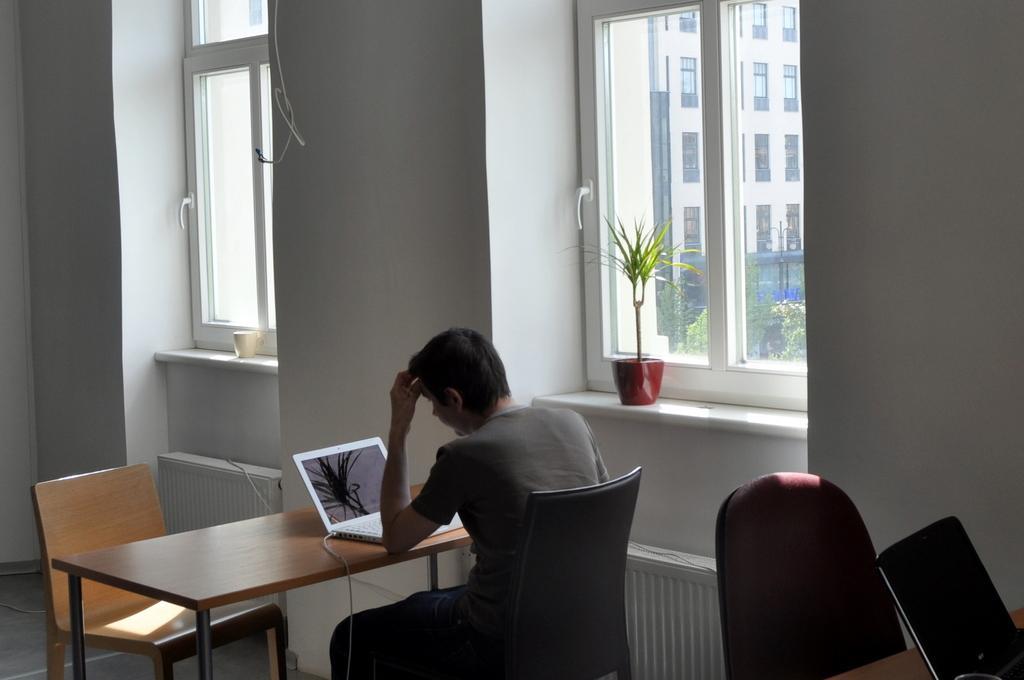Describe this image in one or two sentences. A man is sitting on the table with laptop on top of it. To the right side of him we observe a glass window and a small flower pot. 